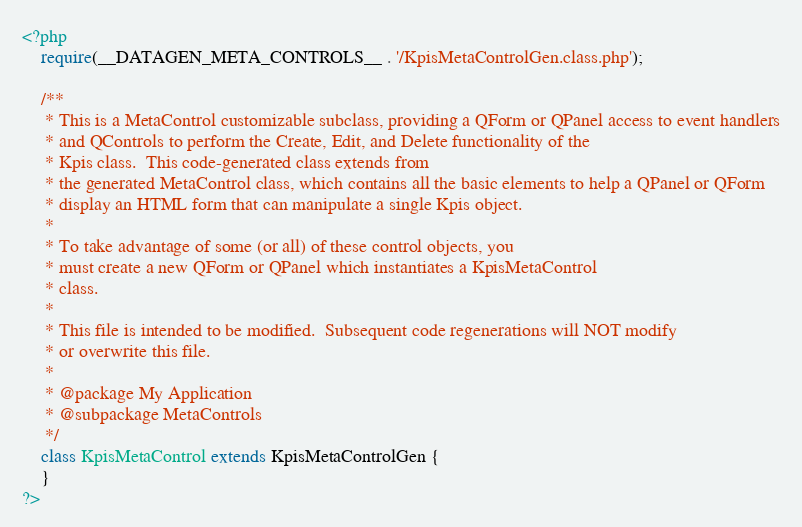<code> <loc_0><loc_0><loc_500><loc_500><_PHP_><?php
	require(__DATAGEN_META_CONTROLS__ . '/KpisMetaControlGen.class.php');

	/**
	 * This is a MetaControl customizable subclass, providing a QForm or QPanel access to event handlers
	 * and QControls to perform the Create, Edit, and Delete functionality of the
	 * Kpis class.  This code-generated class extends from
	 * the generated MetaControl class, which contains all the basic elements to help a QPanel or QForm
	 * display an HTML form that can manipulate a single Kpis object.
	 *
	 * To take advantage of some (or all) of these control objects, you
	 * must create a new QForm or QPanel which instantiates a KpisMetaControl
	 * class.
	 *
	 * This file is intended to be modified.  Subsequent code regenerations will NOT modify
	 * or overwrite this file.
	 * 
	 * @package My Application
	 * @subpackage MetaControls
	 */
	class KpisMetaControl extends KpisMetaControlGen {
	}
?></code> 